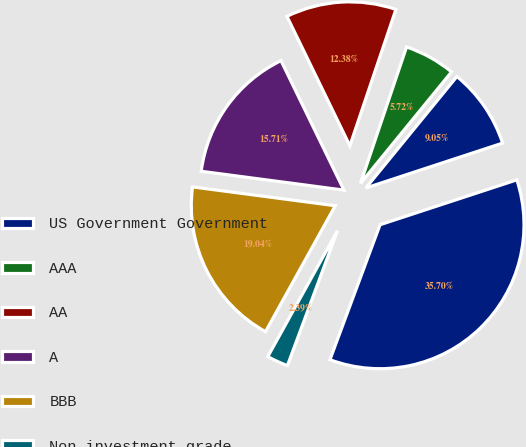Convert chart. <chart><loc_0><loc_0><loc_500><loc_500><pie_chart><fcel>US Government Government<fcel>AAA<fcel>AA<fcel>A<fcel>BBB<fcel>Non-investment grade<fcel>Total<nl><fcel>9.05%<fcel>5.72%<fcel>12.38%<fcel>15.71%<fcel>19.04%<fcel>2.39%<fcel>35.7%<nl></chart> 